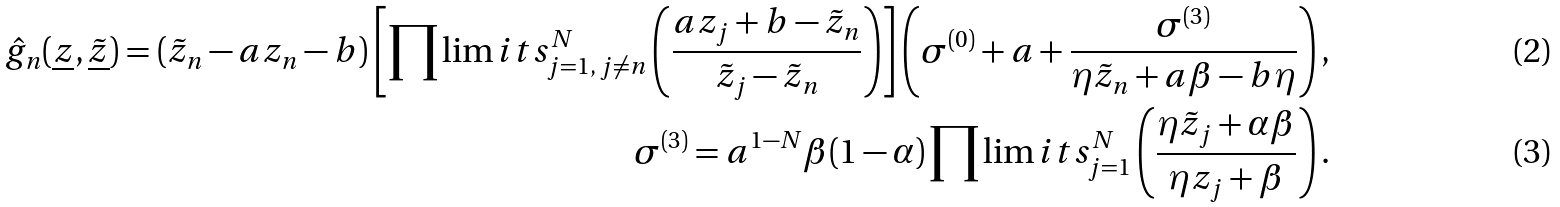Convert formula to latex. <formula><loc_0><loc_0><loc_500><loc_500>\hat { g } _ { n } ( \underline { z } , \underline { \tilde { z } } ) = ( \tilde { z } _ { n } - a z _ { n } - b ) \left [ \prod \lim i t s _ { j = 1 , \, j \neq n } ^ { N } \left ( \frac { a z _ { j } + b - \tilde { z } _ { n } } { \tilde { z } _ { j } - \tilde { z } _ { n } } \right ) \right ] \left ( \sigma ^ { ( 0 ) } + a + \frac { \sigma ^ { ( 3 ) } } { \eta \tilde { z } _ { n } + a \beta - b \eta } \right ) , \\ \sigma ^ { ( 3 ) } = a ^ { 1 - N } \beta ( 1 - \alpha ) \prod \lim i t s _ { j = 1 } ^ { N } \left ( \frac { \eta \tilde { z } _ { j } + \alpha \beta } { \eta z _ { j } + \beta } \right ) .</formula> 